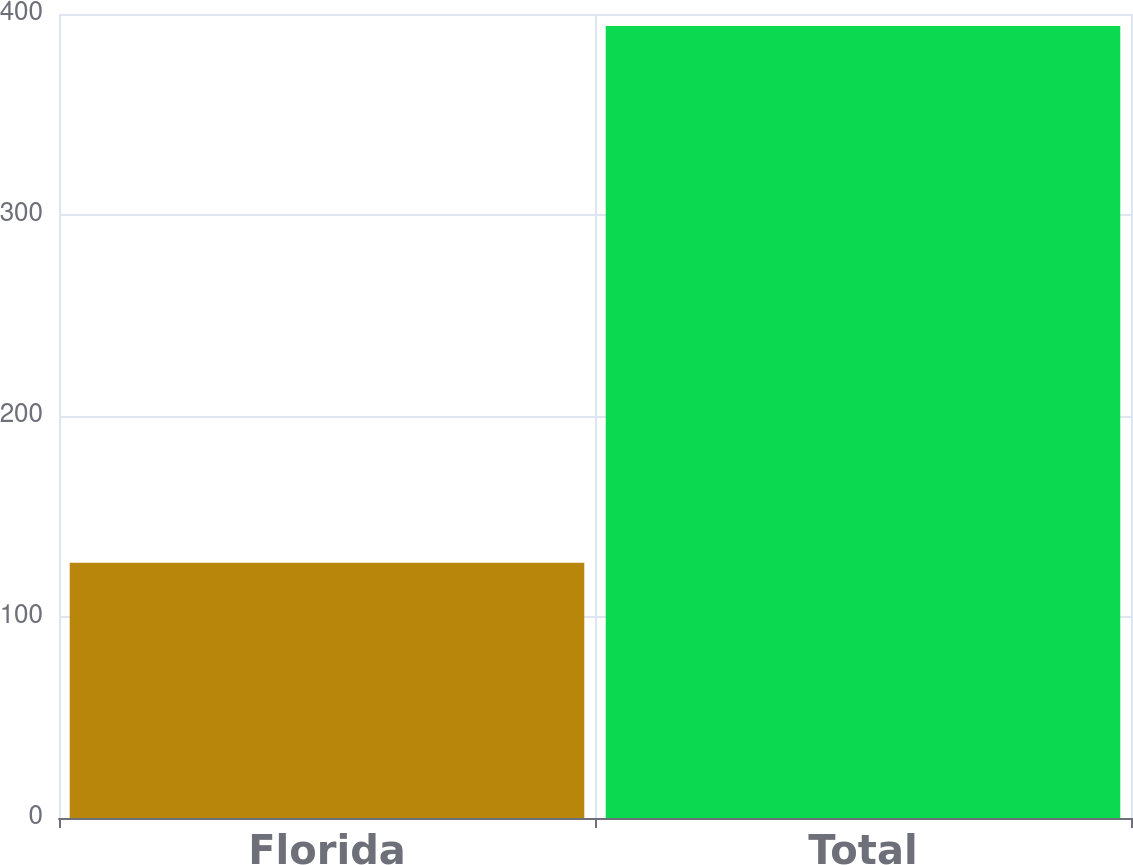Convert chart to OTSL. <chart><loc_0><loc_0><loc_500><loc_500><bar_chart><fcel>Florida<fcel>Total<nl><fcel>127<fcel>394<nl></chart> 